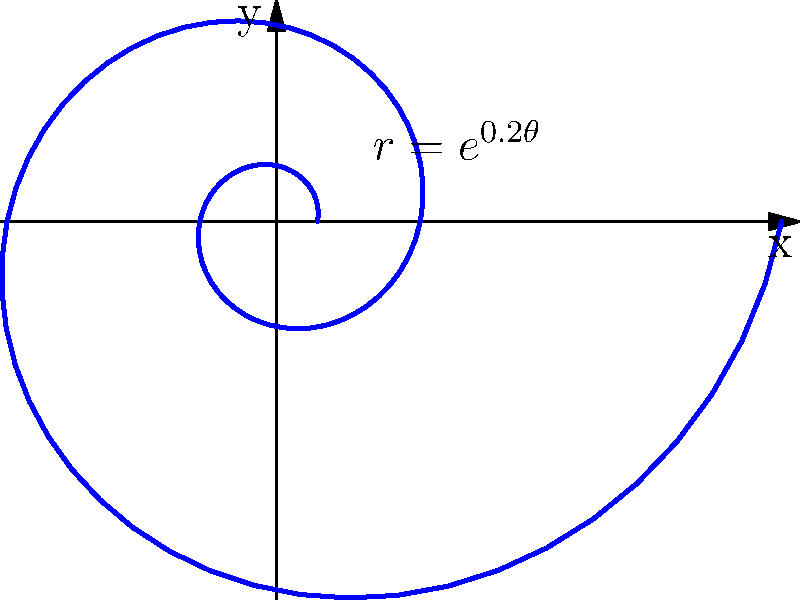In your nature photography, you've captured a stunning image of a nautilus shell. The shell's spiral pattern closely resembles a logarithmic spiral described by the equation $r = e^{0.2\theta}$. If you were to measure the radial distance from the center at $\theta = 2\pi$ and again at $\theta = 4\pi$, what would be the ratio of these two measurements? Let's approach this step-by-step:

1) The logarithmic spiral is described by the equation $r = e^{0.2\theta}$.

2) We need to find the ratio of $r$ at $\theta = 4\pi$ to $r$ at $\theta = 2\pi$.

3) Let's call this ratio $R$. So, $R = \frac{r(\theta = 4\pi)}{r(\theta = 2\pi)}$.

4) For $\theta = 4\pi$:
   $r(4\pi) = e^{0.2(4\pi)} = e^{0.8\pi}$

5) For $\theta = 2\pi$:
   $r(2\pi) = e^{0.2(2\pi)} = e^{0.4\pi}$

6) Now, we can calculate the ratio:
   $R = \frac{e^{0.8\pi}}{e^{0.4\pi}}$

7) Using the properties of exponents, we can simplify this:
   $R = e^{0.8\pi - 0.4\pi} = e^{0.4\pi}$

8) This is our final answer. The ratio of the radial distances is $e^{0.4\pi}$.

This ratio is a constant for any full rotation in a logarithmic spiral, which is why these spirals maintain their shape as they grow, a property often observed in nature.
Answer: $e^{0.4\pi}$ 